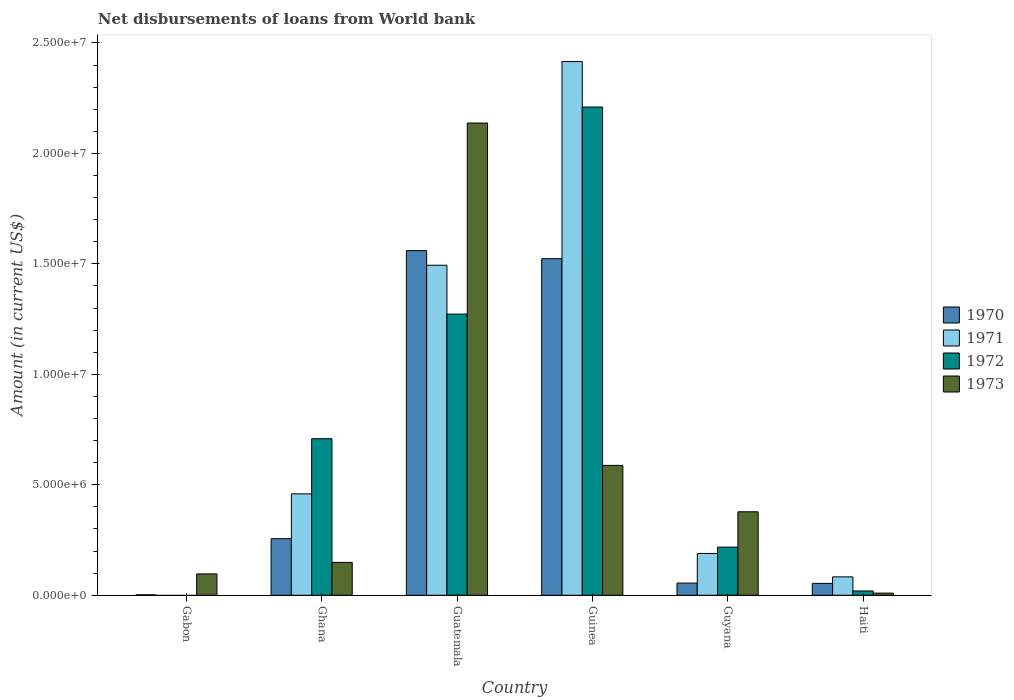How many groups of bars are there?
Keep it short and to the point. 6. Are the number of bars per tick equal to the number of legend labels?
Give a very brief answer. No. Are the number of bars on each tick of the X-axis equal?
Give a very brief answer. No. How many bars are there on the 6th tick from the left?
Your answer should be very brief. 4. How many bars are there on the 3rd tick from the right?
Give a very brief answer. 4. What is the label of the 2nd group of bars from the left?
Your answer should be compact. Ghana. In how many cases, is the number of bars for a given country not equal to the number of legend labels?
Your answer should be compact. 1. What is the amount of loan disbursed from World Bank in 1971 in Guatemala?
Provide a short and direct response. 1.49e+07. Across all countries, what is the maximum amount of loan disbursed from World Bank in 1970?
Provide a succinct answer. 1.56e+07. In which country was the amount of loan disbursed from World Bank in 1973 maximum?
Your answer should be compact. Guatemala. What is the total amount of loan disbursed from World Bank in 1971 in the graph?
Keep it short and to the point. 4.64e+07. What is the difference between the amount of loan disbursed from World Bank in 1973 in Gabon and that in Guinea?
Give a very brief answer. -4.91e+06. What is the difference between the amount of loan disbursed from World Bank in 1971 in Guatemala and the amount of loan disbursed from World Bank in 1970 in Haiti?
Your response must be concise. 1.44e+07. What is the average amount of loan disbursed from World Bank in 1971 per country?
Offer a very short reply. 7.74e+06. What is the difference between the amount of loan disbursed from World Bank of/in 1973 and amount of loan disbursed from World Bank of/in 1971 in Guinea?
Offer a very short reply. -1.83e+07. What is the ratio of the amount of loan disbursed from World Bank in 1971 in Guatemala to that in Guinea?
Give a very brief answer. 0.62. What is the difference between the highest and the second highest amount of loan disbursed from World Bank in 1970?
Your answer should be very brief. 3.64e+05. What is the difference between the highest and the lowest amount of loan disbursed from World Bank in 1970?
Your response must be concise. 1.56e+07. Is it the case that in every country, the sum of the amount of loan disbursed from World Bank in 1971 and amount of loan disbursed from World Bank in 1972 is greater than the sum of amount of loan disbursed from World Bank in 1970 and amount of loan disbursed from World Bank in 1973?
Make the answer very short. No. Is it the case that in every country, the sum of the amount of loan disbursed from World Bank in 1971 and amount of loan disbursed from World Bank in 1973 is greater than the amount of loan disbursed from World Bank in 1970?
Offer a very short reply. Yes. How many bars are there?
Ensure brevity in your answer.  22. How many countries are there in the graph?
Give a very brief answer. 6. What is the difference between two consecutive major ticks on the Y-axis?
Offer a terse response. 5.00e+06. Are the values on the major ticks of Y-axis written in scientific E-notation?
Your answer should be compact. Yes. Does the graph contain any zero values?
Offer a very short reply. Yes. What is the title of the graph?
Ensure brevity in your answer.  Net disbursements of loans from World bank. Does "1993" appear as one of the legend labels in the graph?
Your response must be concise. No. What is the Amount (in current US$) in 1973 in Gabon?
Ensure brevity in your answer.  9.67e+05. What is the Amount (in current US$) in 1970 in Ghana?
Offer a very short reply. 2.56e+06. What is the Amount (in current US$) of 1971 in Ghana?
Provide a short and direct response. 4.59e+06. What is the Amount (in current US$) in 1972 in Ghana?
Offer a very short reply. 7.09e+06. What is the Amount (in current US$) in 1973 in Ghana?
Offer a terse response. 1.49e+06. What is the Amount (in current US$) in 1970 in Guatemala?
Offer a very short reply. 1.56e+07. What is the Amount (in current US$) in 1971 in Guatemala?
Provide a succinct answer. 1.49e+07. What is the Amount (in current US$) in 1972 in Guatemala?
Offer a terse response. 1.27e+07. What is the Amount (in current US$) in 1973 in Guatemala?
Offer a very short reply. 2.14e+07. What is the Amount (in current US$) in 1970 in Guinea?
Give a very brief answer. 1.52e+07. What is the Amount (in current US$) of 1971 in Guinea?
Provide a succinct answer. 2.42e+07. What is the Amount (in current US$) in 1972 in Guinea?
Your response must be concise. 2.21e+07. What is the Amount (in current US$) of 1973 in Guinea?
Offer a very short reply. 5.88e+06. What is the Amount (in current US$) of 1970 in Guyana?
Give a very brief answer. 5.53e+05. What is the Amount (in current US$) in 1971 in Guyana?
Your response must be concise. 1.89e+06. What is the Amount (in current US$) of 1972 in Guyana?
Keep it short and to the point. 2.18e+06. What is the Amount (in current US$) in 1973 in Guyana?
Give a very brief answer. 3.78e+06. What is the Amount (in current US$) in 1970 in Haiti?
Provide a succinct answer. 5.38e+05. What is the Amount (in current US$) of 1971 in Haiti?
Provide a succinct answer. 8.34e+05. What is the Amount (in current US$) of 1972 in Haiti?
Your response must be concise. 1.96e+05. What is the Amount (in current US$) in 1973 in Haiti?
Provide a succinct answer. 9.80e+04. Across all countries, what is the maximum Amount (in current US$) in 1970?
Your answer should be compact. 1.56e+07. Across all countries, what is the maximum Amount (in current US$) in 1971?
Offer a very short reply. 2.42e+07. Across all countries, what is the maximum Amount (in current US$) of 1972?
Your answer should be very brief. 2.21e+07. Across all countries, what is the maximum Amount (in current US$) of 1973?
Your response must be concise. 2.14e+07. Across all countries, what is the minimum Amount (in current US$) of 1970?
Offer a very short reply. 2.00e+04. Across all countries, what is the minimum Amount (in current US$) of 1971?
Keep it short and to the point. 0. Across all countries, what is the minimum Amount (in current US$) of 1972?
Make the answer very short. 0. Across all countries, what is the minimum Amount (in current US$) in 1973?
Your answer should be very brief. 9.80e+04. What is the total Amount (in current US$) of 1970 in the graph?
Keep it short and to the point. 3.45e+07. What is the total Amount (in current US$) of 1971 in the graph?
Offer a terse response. 4.64e+07. What is the total Amount (in current US$) of 1972 in the graph?
Your answer should be very brief. 4.43e+07. What is the total Amount (in current US$) in 1973 in the graph?
Your answer should be compact. 3.36e+07. What is the difference between the Amount (in current US$) of 1970 in Gabon and that in Ghana?
Your response must be concise. -2.54e+06. What is the difference between the Amount (in current US$) of 1973 in Gabon and that in Ghana?
Keep it short and to the point. -5.21e+05. What is the difference between the Amount (in current US$) of 1970 in Gabon and that in Guatemala?
Your answer should be compact. -1.56e+07. What is the difference between the Amount (in current US$) of 1973 in Gabon and that in Guatemala?
Your answer should be compact. -2.04e+07. What is the difference between the Amount (in current US$) of 1970 in Gabon and that in Guinea?
Your response must be concise. -1.52e+07. What is the difference between the Amount (in current US$) in 1973 in Gabon and that in Guinea?
Offer a very short reply. -4.91e+06. What is the difference between the Amount (in current US$) in 1970 in Gabon and that in Guyana?
Your response must be concise. -5.33e+05. What is the difference between the Amount (in current US$) in 1973 in Gabon and that in Guyana?
Your answer should be very brief. -2.81e+06. What is the difference between the Amount (in current US$) of 1970 in Gabon and that in Haiti?
Offer a terse response. -5.18e+05. What is the difference between the Amount (in current US$) of 1973 in Gabon and that in Haiti?
Offer a terse response. 8.69e+05. What is the difference between the Amount (in current US$) of 1970 in Ghana and that in Guatemala?
Give a very brief answer. -1.30e+07. What is the difference between the Amount (in current US$) of 1971 in Ghana and that in Guatemala?
Provide a succinct answer. -1.03e+07. What is the difference between the Amount (in current US$) of 1972 in Ghana and that in Guatemala?
Your answer should be very brief. -5.64e+06. What is the difference between the Amount (in current US$) of 1973 in Ghana and that in Guatemala?
Offer a terse response. -1.99e+07. What is the difference between the Amount (in current US$) in 1970 in Ghana and that in Guinea?
Keep it short and to the point. -1.27e+07. What is the difference between the Amount (in current US$) in 1971 in Ghana and that in Guinea?
Your answer should be compact. -1.96e+07. What is the difference between the Amount (in current US$) in 1972 in Ghana and that in Guinea?
Your answer should be compact. -1.50e+07. What is the difference between the Amount (in current US$) of 1973 in Ghana and that in Guinea?
Your answer should be compact. -4.39e+06. What is the difference between the Amount (in current US$) of 1970 in Ghana and that in Guyana?
Ensure brevity in your answer.  2.01e+06. What is the difference between the Amount (in current US$) of 1971 in Ghana and that in Guyana?
Your response must be concise. 2.70e+06. What is the difference between the Amount (in current US$) of 1972 in Ghana and that in Guyana?
Your answer should be compact. 4.91e+06. What is the difference between the Amount (in current US$) of 1973 in Ghana and that in Guyana?
Provide a short and direct response. -2.29e+06. What is the difference between the Amount (in current US$) of 1970 in Ghana and that in Haiti?
Provide a succinct answer. 2.02e+06. What is the difference between the Amount (in current US$) in 1971 in Ghana and that in Haiti?
Give a very brief answer. 3.76e+06. What is the difference between the Amount (in current US$) in 1972 in Ghana and that in Haiti?
Ensure brevity in your answer.  6.89e+06. What is the difference between the Amount (in current US$) in 1973 in Ghana and that in Haiti?
Provide a short and direct response. 1.39e+06. What is the difference between the Amount (in current US$) of 1970 in Guatemala and that in Guinea?
Give a very brief answer. 3.64e+05. What is the difference between the Amount (in current US$) of 1971 in Guatemala and that in Guinea?
Keep it short and to the point. -9.22e+06. What is the difference between the Amount (in current US$) in 1972 in Guatemala and that in Guinea?
Offer a terse response. -9.37e+06. What is the difference between the Amount (in current US$) in 1973 in Guatemala and that in Guinea?
Your response must be concise. 1.55e+07. What is the difference between the Amount (in current US$) of 1970 in Guatemala and that in Guyana?
Keep it short and to the point. 1.50e+07. What is the difference between the Amount (in current US$) in 1971 in Guatemala and that in Guyana?
Make the answer very short. 1.30e+07. What is the difference between the Amount (in current US$) of 1972 in Guatemala and that in Guyana?
Ensure brevity in your answer.  1.05e+07. What is the difference between the Amount (in current US$) of 1973 in Guatemala and that in Guyana?
Make the answer very short. 1.76e+07. What is the difference between the Amount (in current US$) in 1970 in Guatemala and that in Haiti?
Keep it short and to the point. 1.51e+07. What is the difference between the Amount (in current US$) in 1971 in Guatemala and that in Haiti?
Your response must be concise. 1.41e+07. What is the difference between the Amount (in current US$) in 1972 in Guatemala and that in Haiti?
Give a very brief answer. 1.25e+07. What is the difference between the Amount (in current US$) of 1973 in Guatemala and that in Haiti?
Ensure brevity in your answer.  2.13e+07. What is the difference between the Amount (in current US$) of 1970 in Guinea and that in Guyana?
Provide a short and direct response. 1.47e+07. What is the difference between the Amount (in current US$) of 1971 in Guinea and that in Guyana?
Provide a short and direct response. 2.23e+07. What is the difference between the Amount (in current US$) of 1972 in Guinea and that in Guyana?
Your answer should be very brief. 1.99e+07. What is the difference between the Amount (in current US$) in 1973 in Guinea and that in Guyana?
Provide a succinct answer. 2.10e+06. What is the difference between the Amount (in current US$) of 1970 in Guinea and that in Haiti?
Your answer should be compact. 1.47e+07. What is the difference between the Amount (in current US$) of 1971 in Guinea and that in Haiti?
Make the answer very short. 2.33e+07. What is the difference between the Amount (in current US$) in 1972 in Guinea and that in Haiti?
Provide a succinct answer. 2.19e+07. What is the difference between the Amount (in current US$) in 1973 in Guinea and that in Haiti?
Offer a terse response. 5.78e+06. What is the difference between the Amount (in current US$) in 1970 in Guyana and that in Haiti?
Offer a very short reply. 1.50e+04. What is the difference between the Amount (in current US$) of 1971 in Guyana and that in Haiti?
Your answer should be very brief. 1.06e+06. What is the difference between the Amount (in current US$) in 1972 in Guyana and that in Haiti?
Your answer should be compact. 1.98e+06. What is the difference between the Amount (in current US$) of 1973 in Guyana and that in Haiti?
Your response must be concise. 3.68e+06. What is the difference between the Amount (in current US$) in 1970 in Gabon and the Amount (in current US$) in 1971 in Ghana?
Ensure brevity in your answer.  -4.57e+06. What is the difference between the Amount (in current US$) in 1970 in Gabon and the Amount (in current US$) in 1972 in Ghana?
Offer a terse response. -7.07e+06. What is the difference between the Amount (in current US$) of 1970 in Gabon and the Amount (in current US$) of 1973 in Ghana?
Offer a very short reply. -1.47e+06. What is the difference between the Amount (in current US$) in 1970 in Gabon and the Amount (in current US$) in 1971 in Guatemala?
Your answer should be very brief. -1.49e+07. What is the difference between the Amount (in current US$) in 1970 in Gabon and the Amount (in current US$) in 1972 in Guatemala?
Keep it short and to the point. -1.27e+07. What is the difference between the Amount (in current US$) of 1970 in Gabon and the Amount (in current US$) of 1973 in Guatemala?
Provide a short and direct response. -2.14e+07. What is the difference between the Amount (in current US$) of 1970 in Gabon and the Amount (in current US$) of 1971 in Guinea?
Provide a short and direct response. -2.41e+07. What is the difference between the Amount (in current US$) of 1970 in Gabon and the Amount (in current US$) of 1972 in Guinea?
Offer a terse response. -2.21e+07. What is the difference between the Amount (in current US$) in 1970 in Gabon and the Amount (in current US$) in 1973 in Guinea?
Ensure brevity in your answer.  -5.86e+06. What is the difference between the Amount (in current US$) of 1970 in Gabon and the Amount (in current US$) of 1971 in Guyana?
Your answer should be compact. -1.87e+06. What is the difference between the Amount (in current US$) of 1970 in Gabon and the Amount (in current US$) of 1972 in Guyana?
Your answer should be very brief. -2.16e+06. What is the difference between the Amount (in current US$) in 1970 in Gabon and the Amount (in current US$) in 1973 in Guyana?
Offer a very short reply. -3.76e+06. What is the difference between the Amount (in current US$) of 1970 in Gabon and the Amount (in current US$) of 1971 in Haiti?
Your response must be concise. -8.14e+05. What is the difference between the Amount (in current US$) in 1970 in Gabon and the Amount (in current US$) in 1972 in Haiti?
Keep it short and to the point. -1.76e+05. What is the difference between the Amount (in current US$) in 1970 in Gabon and the Amount (in current US$) in 1973 in Haiti?
Offer a very short reply. -7.80e+04. What is the difference between the Amount (in current US$) of 1970 in Ghana and the Amount (in current US$) of 1971 in Guatemala?
Keep it short and to the point. -1.24e+07. What is the difference between the Amount (in current US$) in 1970 in Ghana and the Amount (in current US$) in 1972 in Guatemala?
Your response must be concise. -1.02e+07. What is the difference between the Amount (in current US$) in 1970 in Ghana and the Amount (in current US$) in 1973 in Guatemala?
Your response must be concise. -1.88e+07. What is the difference between the Amount (in current US$) in 1971 in Ghana and the Amount (in current US$) in 1972 in Guatemala?
Your answer should be compact. -8.14e+06. What is the difference between the Amount (in current US$) in 1971 in Ghana and the Amount (in current US$) in 1973 in Guatemala?
Ensure brevity in your answer.  -1.68e+07. What is the difference between the Amount (in current US$) in 1972 in Ghana and the Amount (in current US$) in 1973 in Guatemala?
Your response must be concise. -1.43e+07. What is the difference between the Amount (in current US$) in 1970 in Ghana and the Amount (in current US$) in 1971 in Guinea?
Your response must be concise. -2.16e+07. What is the difference between the Amount (in current US$) of 1970 in Ghana and the Amount (in current US$) of 1972 in Guinea?
Your answer should be very brief. -1.95e+07. What is the difference between the Amount (in current US$) in 1970 in Ghana and the Amount (in current US$) in 1973 in Guinea?
Keep it short and to the point. -3.32e+06. What is the difference between the Amount (in current US$) of 1971 in Ghana and the Amount (in current US$) of 1972 in Guinea?
Offer a terse response. -1.75e+07. What is the difference between the Amount (in current US$) in 1971 in Ghana and the Amount (in current US$) in 1973 in Guinea?
Make the answer very short. -1.29e+06. What is the difference between the Amount (in current US$) of 1972 in Ghana and the Amount (in current US$) of 1973 in Guinea?
Your answer should be compact. 1.21e+06. What is the difference between the Amount (in current US$) of 1970 in Ghana and the Amount (in current US$) of 1971 in Guyana?
Keep it short and to the point. 6.69e+05. What is the difference between the Amount (in current US$) of 1970 in Ghana and the Amount (in current US$) of 1972 in Guyana?
Your answer should be compact. 3.82e+05. What is the difference between the Amount (in current US$) in 1970 in Ghana and the Amount (in current US$) in 1973 in Guyana?
Provide a short and direct response. -1.22e+06. What is the difference between the Amount (in current US$) in 1971 in Ghana and the Amount (in current US$) in 1972 in Guyana?
Offer a terse response. 2.41e+06. What is the difference between the Amount (in current US$) of 1971 in Ghana and the Amount (in current US$) of 1973 in Guyana?
Keep it short and to the point. 8.12e+05. What is the difference between the Amount (in current US$) in 1972 in Ghana and the Amount (in current US$) in 1973 in Guyana?
Offer a terse response. 3.31e+06. What is the difference between the Amount (in current US$) in 1970 in Ghana and the Amount (in current US$) in 1971 in Haiti?
Give a very brief answer. 1.73e+06. What is the difference between the Amount (in current US$) of 1970 in Ghana and the Amount (in current US$) of 1972 in Haiti?
Give a very brief answer. 2.37e+06. What is the difference between the Amount (in current US$) in 1970 in Ghana and the Amount (in current US$) in 1973 in Haiti?
Give a very brief answer. 2.46e+06. What is the difference between the Amount (in current US$) in 1971 in Ghana and the Amount (in current US$) in 1972 in Haiti?
Provide a short and direct response. 4.40e+06. What is the difference between the Amount (in current US$) in 1971 in Ghana and the Amount (in current US$) in 1973 in Haiti?
Offer a very short reply. 4.49e+06. What is the difference between the Amount (in current US$) of 1972 in Ghana and the Amount (in current US$) of 1973 in Haiti?
Your answer should be very brief. 6.99e+06. What is the difference between the Amount (in current US$) of 1970 in Guatemala and the Amount (in current US$) of 1971 in Guinea?
Keep it short and to the point. -8.56e+06. What is the difference between the Amount (in current US$) in 1970 in Guatemala and the Amount (in current US$) in 1972 in Guinea?
Make the answer very short. -6.50e+06. What is the difference between the Amount (in current US$) in 1970 in Guatemala and the Amount (in current US$) in 1973 in Guinea?
Make the answer very short. 9.72e+06. What is the difference between the Amount (in current US$) in 1971 in Guatemala and the Amount (in current US$) in 1972 in Guinea?
Offer a very short reply. -7.16e+06. What is the difference between the Amount (in current US$) of 1971 in Guatemala and the Amount (in current US$) of 1973 in Guinea?
Keep it short and to the point. 9.06e+06. What is the difference between the Amount (in current US$) of 1972 in Guatemala and the Amount (in current US$) of 1973 in Guinea?
Ensure brevity in your answer.  6.85e+06. What is the difference between the Amount (in current US$) of 1970 in Guatemala and the Amount (in current US$) of 1971 in Guyana?
Your response must be concise. 1.37e+07. What is the difference between the Amount (in current US$) of 1970 in Guatemala and the Amount (in current US$) of 1972 in Guyana?
Your response must be concise. 1.34e+07. What is the difference between the Amount (in current US$) in 1970 in Guatemala and the Amount (in current US$) in 1973 in Guyana?
Your answer should be compact. 1.18e+07. What is the difference between the Amount (in current US$) in 1971 in Guatemala and the Amount (in current US$) in 1972 in Guyana?
Ensure brevity in your answer.  1.28e+07. What is the difference between the Amount (in current US$) in 1971 in Guatemala and the Amount (in current US$) in 1973 in Guyana?
Provide a short and direct response. 1.12e+07. What is the difference between the Amount (in current US$) of 1972 in Guatemala and the Amount (in current US$) of 1973 in Guyana?
Provide a short and direct response. 8.95e+06. What is the difference between the Amount (in current US$) in 1970 in Guatemala and the Amount (in current US$) in 1971 in Haiti?
Provide a succinct answer. 1.48e+07. What is the difference between the Amount (in current US$) in 1970 in Guatemala and the Amount (in current US$) in 1972 in Haiti?
Give a very brief answer. 1.54e+07. What is the difference between the Amount (in current US$) of 1970 in Guatemala and the Amount (in current US$) of 1973 in Haiti?
Provide a short and direct response. 1.55e+07. What is the difference between the Amount (in current US$) of 1971 in Guatemala and the Amount (in current US$) of 1972 in Haiti?
Your response must be concise. 1.47e+07. What is the difference between the Amount (in current US$) of 1971 in Guatemala and the Amount (in current US$) of 1973 in Haiti?
Your answer should be very brief. 1.48e+07. What is the difference between the Amount (in current US$) of 1972 in Guatemala and the Amount (in current US$) of 1973 in Haiti?
Give a very brief answer. 1.26e+07. What is the difference between the Amount (in current US$) in 1970 in Guinea and the Amount (in current US$) in 1971 in Guyana?
Your answer should be compact. 1.33e+07. What is the difference between the Amount (in current US$) of 1970 in Guinea and the Amount (in current US$) of 1972 in Guyana?
Provide a short and direct response. 1.31e+07. What is the difference between the Amount (in current US$) in 1970 in Guinea and the Amount (in current US$) in 1973 in Guyana?
Provide a succinct answer. 1.15e+07. What is the difference between the Amount (in current US$) in 1971 in Guinea and the Amount (in current US$) in 1972 in Guyana?
Provide a short and direct response. 2.20e+07. What is the difference between the Amount (in current US$) of 1971 in Guinea and the Amount (in current US$) of 1973 in Guyana?
Offer a very short reply. 2.04e+07. What is the difference between the Amount (in current US$) of 1972 in Guinea and the Amount (in current US$) of 1973 in Guyana?
Give a very brief answer. 1.83e+07. What is the difference between the Amount (in current US$) in 1970 in Guinea and the Amount (in current US$) in 1971 in Haiti?
Provide a short and direct response. 1.44e+07. What is the difference between the Amount (in current US$) in 1970 in Guinea and the Amount (in current US$) in 1972 in Haiti?
Your response must be concise. 1.50e+07. What is the difference between the Amount (in current US$) in 1970 in Guinea and the Amount (in current US$) in 1973 in Haiti?
Make the answer very short. 1.51e+07. What is the difference between the Amount (in current US$) in 1971 in Guinea and the Amount (in current US$) in 1972 in Haiti?
Keep it short and to the point. 2.40e+07. What is the difference between the Amount (in current US$) in 1971 in Guinea and the Amount (in current US$) in 1973 in Haiti?
Provide a short and direct response. 2.41e+07. What is the difference between the Amount (in current US$) of 1972 in Guinea and the Amount (in current US$) of 1973 in Haiti?
Offer a terse response. 2.20e+07. What is the difference between the Amount (in current US$) in 1970 in Guyana and the Amount (in current US$) in 1971 in Haiti?
Offer a very short reply. -2.81e+05. What is the difference between the Amount (in current US$) of 1970 in Guyana and the Amount (in current US$) of 1972 in Haiti?
Offer a terse response. 3.57e+05. What is the difference between the Amount (in current US$) of 1970 in Guyana and the Amount (in current US$) of 1973 in Haiti?
Provide a succinct answer. 4.55e+05. What is the difference between the Amount (in current US$) of 1971 in Guyana and the Amount (in current US$) of 1972 in Haiti?
Ensure brevity in your answer.  1.70e+06. What is the difference between the Amount (in current US$) of 1971 in Guyana and the Amount (in current US$) of 1973 in Haiti?
Provide a short and direct response. 1.80e+06. What is the difference between the Amount (in current US$) of 1972 in Guyana and the Amount (in current US$) of 1973 in Haiti?
Your answer should be compact. 2.08e+06. What is the average Amount (in current US$) of 1970 per country?
Your response must be concise. 5.75e+06. What is the average Amount (in current US$) of 1971 per country?
Give a very brief answer. 7.74e+06. What is the average Amount (in current US$) of 1972 per country?
Offer a terse response. 7.38e+06. What is the average Amount (in current US$) of 1973 per country?
Provide a short and direct response. 5.60e+06. What is the difference between the Amount (in current US$) of 1970 and Amount (in current US$) of 1973 in Gabon?
Give a very brief answer. -9.47e+05. What is the difference between the Amount (in current US$) of 1970 and Amount (in current US$) of 1971 in Ghana?
Your answer should be compact. -2.03e+06. What is the difference between the Amount (in current US$) of 1970 and Amount (in current US$) of 1972 in Ghana?
Your response must be concise. -4.53e+06. What is the difference between the Amount (in current US$) in 1970 and Amount (in current US$) in 1973 in Ghana?
Make the answer very short. 1.07e+06. What is the difference between the Amount (in current US$) in 1971 and Amount (in current US$) in 1972 in Ghana?
Provide a succinct answer. -2.50e+06. What is the difference between the Amount (in current US$) of 1971 and Amount (in current US$) of 1973 in Ghana?
Offer a terse response. 3.10e+06. What is the difference between the Amount (in current US$) in 1972 and Amount (in current US$) in 1973 in Ghana?
Provide a short and direct response. 5.60e+06. What is the difference between the Amount (in current US$) in 1970 and Amount (in current US$) in 1972 in Guatemala?
Provide a succinct answer. 2.87e+06. What is the difference between the Amount (in current US$) in 1970 and Amount (in current US$) in 1973 in Guatemala?
Your response must be concise. -5.78e+06. What is the difference between the Amount (in current US$) of 1971 and Amount (in current US$) of 1972 in Guatemala?
Your response must be concise. 2.21e+06. What is the difference between the Amount (in current US$) of 1971 and Amount (in current US$) of 1973 in Guatemala?
Make the answer very short. -6.44e+06. What is the difference between the Amount (in current US$) in 1972 and Amount (in current US$) in 1973 in Guatemala?
Your answer should be very brief. -8.65e+06. What is the difference between the Amount (in current US$) of 1970 and Amount (in current US$) of 1971 in Guinea?
Keep it short and to the point. -8.92e+06. What is the difference between the Amount (in current US$) of 1970 and Amount (in current US$) of 1972 in Guinea?
Your answer should be compact. -6.86e+06. What is the difference between the Amount (in current US$) in 1970 and Amount (in current US$) in 1973 in Guinea?
Provide a succinct answer. 9.36e+06. What is the difference between the Amount (in current US$) of 1971 and Amount (in current US$) of 1972 in Guinea?
Your response must be concise. 2.06e+06. What is the difference between the Amount (in current US$) in 1971 and Amount (in current US$) in 1973 in Guinea?
Offer a very short reply. 1.83e+07. What is the difference between the Amount (in current US$) in 1972 and Amount (in current US$) in 1973 in Guinea?
Make the answer very short. 1.62e+07. What is the difference between the Amount (in current US$) of 1970 and Amount (in current US$) of 1971 in Guyana?
Provide a succinct answer. -1.34e+06. What is the difference between the Amount (in current US$) of 1970 and Amount (in current US$) of 1972 in Guyana?
Offer a terse response. -1.63e+06. What is the difference between the Amount (in current US$) in 1970 and Amount (in current US$) in 1973 in Guyana?
Give a very brief answer. -3.23e+06. What is the difference between the Amount (in current US$) in 1971 and Amount (in current US$) in 1972 in Guyana?
Provide a succinct answer. -2.87e+05. What is the difference between the Amount (in current US$) in 1971 and Amount (in current US$) in 1973 in Guyana?
Keep it short and to the point. -1.89e+06. What is the difference between the Amount (in current US$) in 1972 and Amount (in current US$) in 1973 in Guyana?
Offer a very short reply. -1.60e+06. What is the difference between the Amount (in current US$) in 1970 and Amount (in current US$) in 1971 in Haiti?
Your answer should be very brief. -2.96e+05. What is the difference between the Amount (in current US$) of 1970 and Amount (in current US$) of 1972 in Haiti?
Provide a short and direct response. 3.42e+05. What is the difference between the Amount (in current US$) of 1970 and Amount (in current US$) of 1973 in Haiti?
Provide a short and direct response. 4.40e+05. What is the difference between the Amount (in current US$) in 1971 and Amount (in current US$) in 1972 in Haiti?
Offer a terse response. 6.38e+05. What is the difference between the Amount (in current US$) of 1971 and Amount (in current US$) of 1973 in Haiti?
Provide a succinct answer. 7.36e+05. What is the difference between the Amount (in current US$) of 1972 and Amount (in current US$) of 1973 in Haiti?
Make the answer very short. 9.80e+04. What is the ratio of the Amount (in current US$) in 1970 in Gabon to that in Ghana?
Your response must be concise. 0.01. What is the ratio of the Amount (in current US$) of 1973 in Gabon to that in Ghana?
Provide a short and direct response. 0.65. What is the ratio of the Amount (in current US$) of 1970 in Gabon to that in Guatemala?
Your response must be concise. 0. What is the ratio of the Amount (in current US$) of 1973 in Gabon to that in Guatemala?
Provide a short and direct response. 0.05. What is the ratio of the Amount (in current US$) in 1970 in Gabon to that in Guinea?
Keep it short and to the point. 0. What is the ratio of the Amount (in current US$) of 1973 in Gabon to that in Guinea?
Offer a very short reply. 0.16. What is the ratio of the Amount (in current US$) in 1970 in Gabon to that in Guyana?
Ensure brevity in your answer.  0.04. What is the ratio of the Amount (in current US$) of 1973 in Gabon to that in Guyana?
Ensure brevity in your answer.  0.26. What is the ratio of the Amount (in current US$) of 1970 in Gabon to that in Haiti?
Your answer should be very brief. 0.04. What is the ratio of the Amount (in current US$) in 1973 in Gabon to that in Haiti?
Offer a very short reply. 9.87. What is the ratio of the Amount (in current US$) in 1970 in Ghana to that in Guatemala?
Make the answer very short. 0.16. What is the ratio of the Amount (in current US$) of 1971 in Ghana to that in Guatemala?
Provide a succinct answer. 0.31. What is the ratio of the Amount (in current US$) of 1972 in Ghana to that in Guatemala?
Give a very brief answer. 0.56. What is the ratio of the Amount (in current US$) of 1973 in Ghana to that in Guatemala?
Your answer should be compact. 0.07. What is the ratio of the Amount (in current US$) of 1970 in Ghana to that in Guinea?
Provide a short and direct response. 0.17. What is the ratio of the Amount (in current US$) of 1971 in Ghana to that in Guinea?
Offer a very short reply. 0.19. What is the ratio of the Amount (in current US$) in 1972 in Ghana to that in Guinea?
Make the answer very short. 0.32. What is the ratio of the Amount (in current US$) in 1973 in Ghana to that in Guinea?
Provide a succinct answer. 0.25. What is the ratio of the Amount (in current US$) of 1970 in Ghana to that in Guyana?
Make the answer very short. 4.63. What is the ratio of the Amount (in current US$) of 1971 in Ghana to that in Guyana?
Your response must be concise. 2.43. What is the ratio of the Amount (in current US$) in 1972 in Ghana to that in Guyana?
Your answer should be compact. 3.25. What is the ratio of the Amount (in current US$) of 1973 in Ghana to that in Guyana?
Make the answer very short. 0.39. What is the ratio of the Amount (in current US$) in 1970 in Ghana to that in Haiti?
Your response must be concise. 4.76. What is the ratio of the Amount (in current US$) in 1971 in Ghana to that in Haiti?
Your response must be concise. 5.5. What is the ratio of the Amount (in current US$) in 1972 in Ghana to that in Haiti?
Your answer should be compact. 36.16. What is the ratio of the Amount (in current US$) in 1973 in Ghana to that in Haiti?
Provide a short and direct response. 15.18. What is the ratio of the Amount (in current US$) of 1970 in Guatemala to that in Guinea?
Keep it short and to the point. 1.02. What is the ratio of the Amount (in current US$) in 1971 in Guatemala to that in Guinea?
Your response must be concise. 0.62. What is the ratio of the Amount (in current US$) of 1972 in Guatemala to that in Guinea?
Ensure brevity in your answer.  0.58. What is the ratio of the Amount (in current US$) in 1973 in Guatemala to that in Guinea?
Provide a short and direct response. 3.64. What is the ratio of the Amount (in current US$) in 1970 in Guatemala to that in Guyana?
Provide a short and direct response. 28.21. What is the ratio of the Amount (in current US$) in 1971 in Guatemala to that in Guyana?
Keep it short and to the point. 7.89. What is the ratio of the Amount (in current US$) of 1972 in Guatemala to that in Guyana?
Your response must be concise. 5.84. What is the ratio of the Amount (in current US$) of 1973 in Guatemala to that in Guyana?
Your response must be concise. 5.66. What is the ratio of the Amount (in current US$) of 1970 in Guatemala to that in Haiti?
Make the answer very short. 29. What is the ratio of the Amount (in current US$) of 1971 in Guatemala to that in Haiti?
Offer a terse response. 17.91. What is the ratio of the Amount (in current US$) of 1972 in Guatemala to that in Haiti?
Keep it short and to the point. 64.94. What is the ratio of the Amount (in current US$) of 1973 in Guatemala to that in Haiti?
Your answer should be very brief. 218.13. What is the ratio of the Amount (in current US$) in 1970 in Guinea to that in Guyana?
Give a very brief answer. 27.55. What is the ratio of the Amount (in current US$) in 1971 in Guinea to that in Guyana?
Provide a short and direct response. 12.76. What is the ratio of the Amount (in current US$) of 1972 in Guinea to that in Guyana?
Your response must be concise. 10.14. What is the ratio of the Amount (in current US$) in 1973 in Guinea to that in Guyana?
Offer a very short reply. 1.56. What is the ratio of the Amount (in current US$) of 1970 in Guinea to that in Haiti?
Provide a succinct answer. 28.32. What is the ratio of the Amount (in current US$) in 1971 in Guinea to that in Haiti?
Give a very brief answer. 28.97. What is the ratio of the Amount (in current US$) of 1972 in Guinea to that in Haiti?
Provide a short and direct response. 112.76. What is the ratio of the Amount (in current US$) in 1973 in Guinea to that in Haiti?
Make the answer very short. 60. What is the ratio of the Amount (in current US$) in 1970 in Guyana to that in Haiti?
Offer a very short reply. 1.03. What is the ratio of the Amount (in current US$) of 1971 in Guyana to that in Haiti?
Provide a succinct answer. 2.27. What is the ratio of the Amount (in current US$) in 1972 in Guyana to that in Haiti?
Your answer should be compact. 11.12. What is the ratio of the Amount (in current US$) of 1973 in Guyana to that in Haiti?
Give a very brief answer. 38.56. What is the difference between the highest and the second highest Amount (in current US$) in 1970?
Provide a short and direct response. 3.64e+05. What is the difference between the highest and the second highest Amount (in current US$) of 1971?
Ensure brevity in your answer.  9.22e+06. What is the difference between the highest and the second highest Amount (in current US$) in 1972?
Your answer should be compact. 9.37e+06. What is the difference between the highest and the second highest Amount (in current US$) in 1973?
Offer a terse response. 1.55e+07. What is the difference between the highest and the lowest Amount (in current US$) in 1970?
Keep it short and to the point. 1.56e+07. What is the difference between the highest and the lowest Amount (in current US$) in 1971?
Offer a terse response. 2.42e+07. What is the difference between the highest and the lowest Amount (in current US$) in 1972?
Your response must be concise. 2.21e+07. What is the difference between the highest and the lowest Amount (in current US$) of 1973?
Make the answer very short. 2.13e+07. 